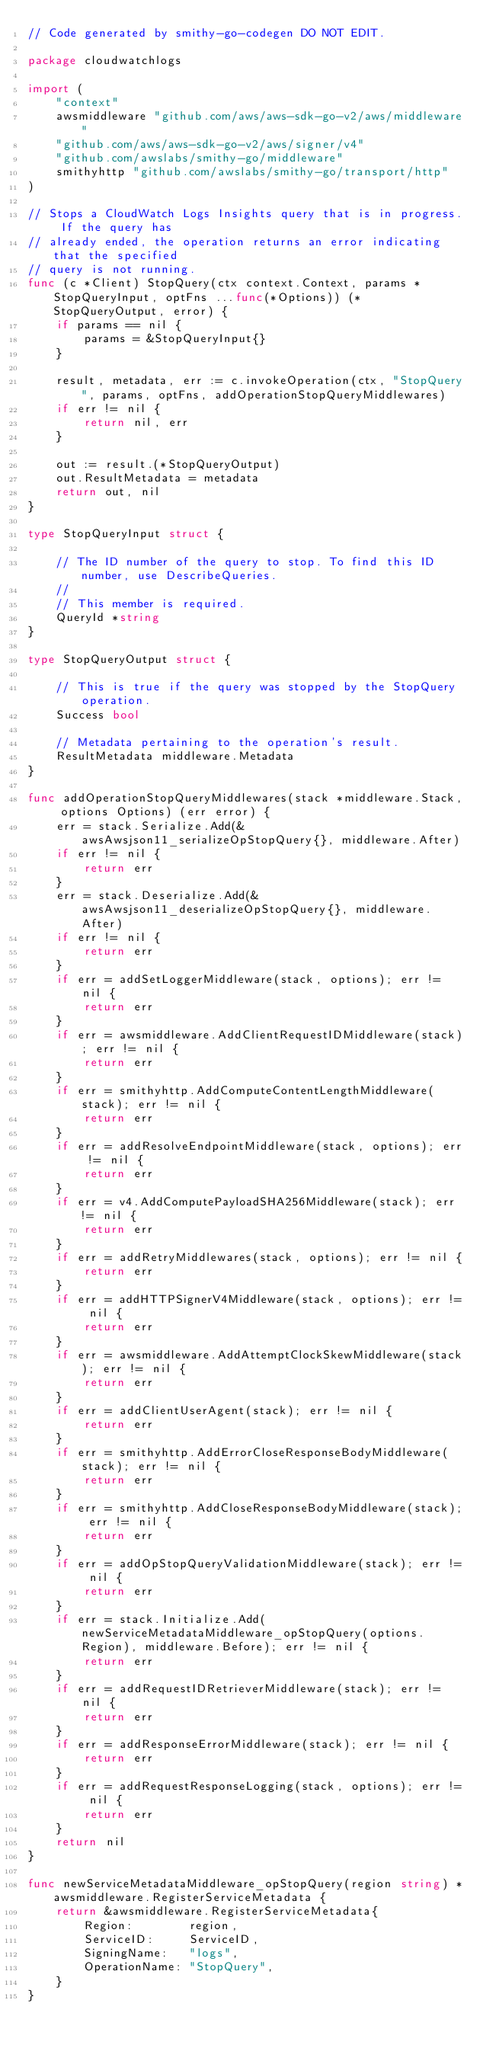Convert code to text. <code><loc_0><loc_0><loc_500><loc_500><_Go_>// Code generated by smithy-go-codegen DO NOT EDIT.

package cloudwatchlogs

import (
	"context"
	awsmiddleware "github.com/aws/aws-sdk-go-v2/aws/middleware"
	"github.com/aws/aws-sdk-go-v2/aws/signer/v4"
	"github.com/awslabs/smithy-go/middleware"
	smithyhttp "github.com/awslabs/smithy-go/transport/http"
)

// Stops a CloudWatch Logs Insights query that is in progress. If the query has
// already ended, the operation returns an error indicating that the specified
// query is not running.
func (c *Client) StopQuery(ctx context.Context, params *StopQueryInput, optFns ...func(*Options)) (*StopQueryOutput, error) {
	if params == nil {
		params = &StopQueryInput{}
	}

	result, metadata, err := c.invokeOperation(ctx, "StopQuery", params, optFns, addOperationStopQueryMiddlewares)
	if err != nil {
		return nil, err
	}

	out := result.(*StopQueryOutput)
	out.ResultMetadata = metadata
	return out, nil
}

type StopQueryInput struct {

	// The ID number of the query to stop. To find this ID number, use DescribeQueries.
	//
	// This member is required.
	QueryId *string
}

type StopQueryOutput struct {

	// This is true if the query was stopped by the StopQuery operation.
	Success bool

	// Metadata pertaining to the operation's result.
	ResultMetadata middleware.Metadata
}

func addOperationStopQueryMiddlewares(stack *middleware.Stack, options Options) (err error) {
	err = stack.Serialize.Add(&awsAwsjson11_serializeOpStopQuery{}, middleware.After)
	if err != nil {
		return err
	}
	err = stack.Deserialize.Add(&awsAwsjson11_deserializeOpStopQuery{}, middleware.After)
	if err != nil {
		return err
	}
	if err = addSetLoggerMiddleware(stack, options); err != nil {
		return err
	}
	if err = awsmiddleware.AddClientRequestIDMiddleware(stack); err != nil {
		return err
	}
	if err = smithyhttp.AddComputeContentLengthMiddleware(stack); err != nil {
		return err
	}
	if err = addResolveEndpointMiddleware(stack, options); err != nil {
		return err
	}
	if err = v4.AddComputePayloadSHA256Middleware(stack); err != nil {
		return err
	}
	if err = addRetryMiddlewares(stack, options); err != nil {
		return err
	}
	if err = addHTTPSignerV4Middleware(stack, options); err != nil {
		return err
	}
	if err = awsmiddleware.AddAttemptClockSkewMiddleware(stack); err != nil {
		return err
	}
	if err = addClientUserAgent(stack); err != nil {
		return err
	}
	if err = smithyhttp.AddErrorCloseResponseBodyMiddleware(stack); err != nil {
		return err
	}
	if err = smithyhttp.AddCloseResponseBodyMiddleware(stack); err != nil {
		return err
	}
	if err = addOpStopQueryValidationMiddleware(stack); err != nil {
		return err
	}
	if err = stack.Initialize.Add(newServiceMetadataMiddleware_opStopQuery(options.Region), middleware.Before); err != nil {
		return err
	}
	if err = addRequestIDRetrieverMiddleware(stack); err != nil {
		return err
	}
	if err = addResponseErrorMiddleware(stack); err != nil {
		return err
	}
	if err = addRequestResponseLogging(stack, options); err != nil {
		return err
	}
	return nil
}

func newServiceMetadataMiddleware_opStopQuery(region string) *awsmiddleware.RegisterServiceMetadata {
	return &awsmiddleware.RegisterServiceMetadata{
		Region:        region,
		ServiceID:     ServiceID,
		SigningName:   "logs",
		OperationName: "StopQuery",
	}
}
</code> 